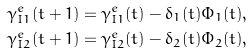<formula> <loc_0><loc_0><loc_500><loc_500>& \gamma _ { I 1 } ^ { e } ( t + 1 ) = \gamma _ { I 1 } ^ { e } ( t ) - \delta _ { 1 } ( t ) \Phi _ { 1 } ( t ) , \\ & \gamma _ { I 2 } ^ { e } ( t + 1 ) = \gamma _ { I 2 } ^ { e } ( t ) - \delta _ { 2 } ( t ) \Phi _ { 2 } ( t ) ,</formula> 